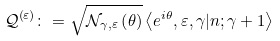Convert formula to latex. <formula><loc_0><loc_0><loc_500><loc_500>\mathcal { Q } ^ { \left ( \varepsilon \right ) } \colon = \sqrt { \mathcal { N } _ { \gamma , \varepsilon } \left ( \theta \right ) } \left \langle e ^ { i \theta } , \varepsilon , \gamma | n ; \gamma + 1 \right \rangle</formula> 